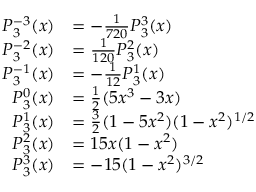Convert formula to latex. <formula><loc_0><loc_0><loc_500><loc_500>{ \begin{array} { r l } { P _ { 3 } ^ { - 3 } ( x ) } & { = - { \frac { 1 } { 7 2 0 } } P _ { 3 } ^ { 3 } ( x ) } \\ { P _ { 3 } ^ { - 2 } ( x ) } & { = { \frac { 1 } { 1 2 0 } } P _ { 3 } ^ { 2 } ( x ) } \\ { P _ { 3 } ^ { - 1 } ( x ) } & { = - { \frac { 1 } { 1 2 } } P _ { 3 } ^ { 1 } ( x ) } \\ { P _ { 3 } ^ { 0 } ( x ) } & { = { \frac { 1 } { 2 } } ( 5 x ^ { 3 } - 3 x ) } \\ { P _ { 3 } ^ { 1 } ( x ) } & { = { \frac { 3 } { 2 } } ( 1 - 5 x ^ { 2 } ) ( 1 - x ^ { 2 } ) ^ { 1 / 2 } } \\ { P _ { 3 } ^ { 2 } ( x ) } & { = 1 5 x ( 1 - x ^ { 2 } ) } \\ { P _ { 3 } ^ { 3 } ( x ) } & { = - 1 5 ( 1 - x ^ { 2 } ) ^ { 3 / 2 } } \end{array} }</formula> 